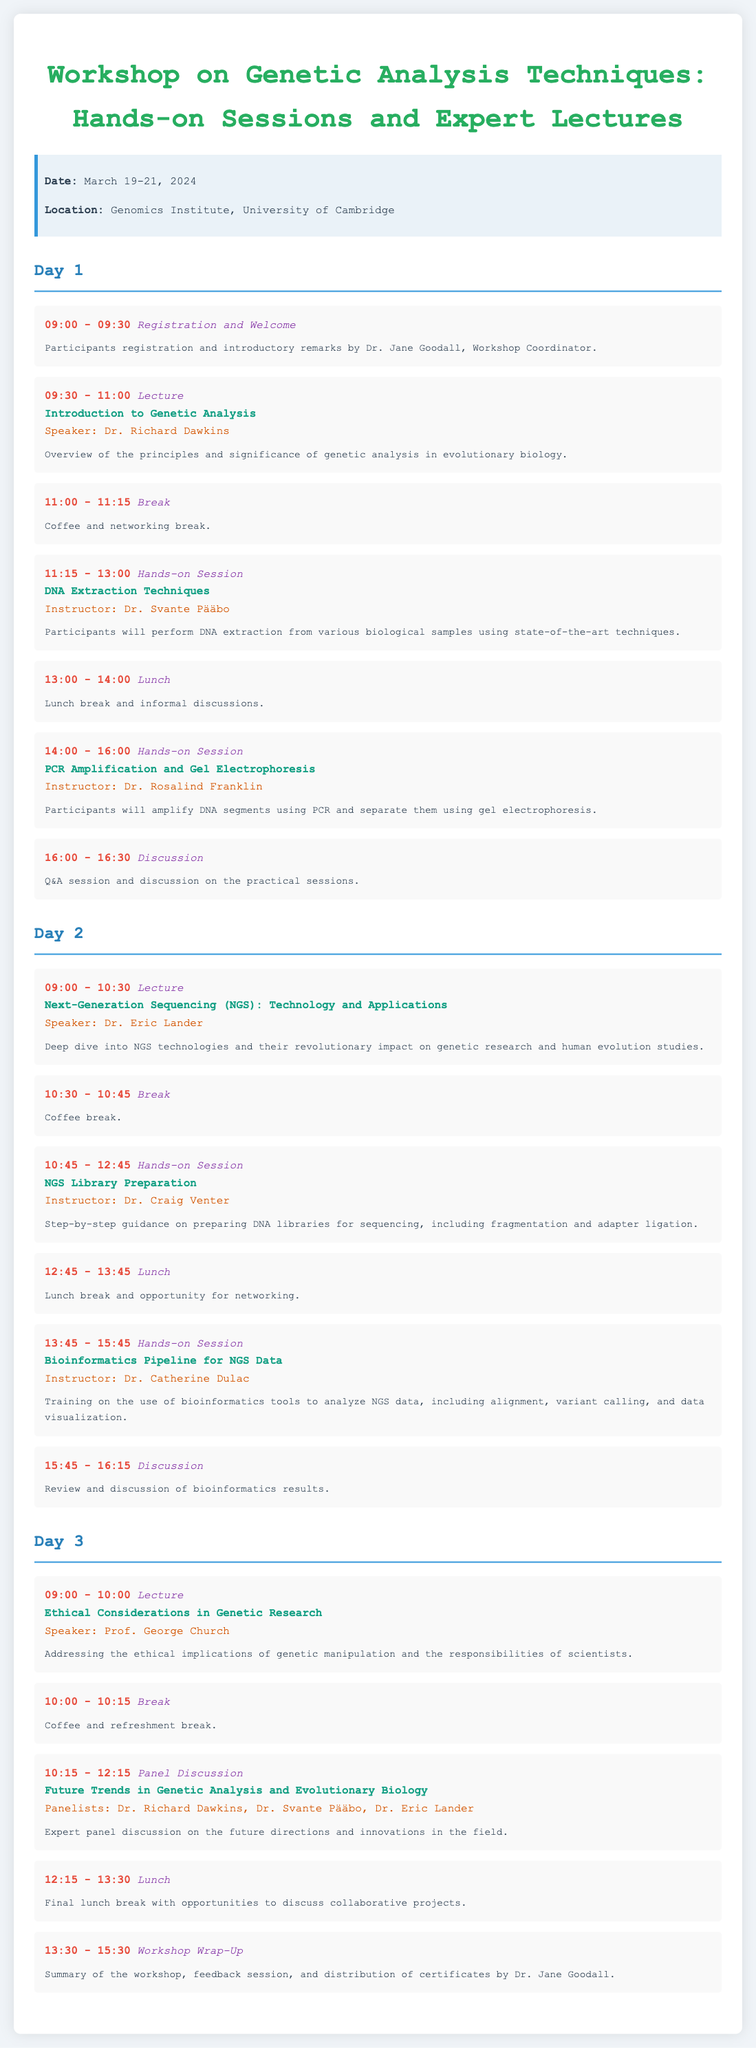what are the dates of the workshop? The dates of the workshop are clearly mentioned at the beginning of the document.
Answer: March 19-21, 2024 who is the speaker for the "Introduction to Genetic Analysis" lecture? The speaker for this lecture is listed in the schedule for Day 1.
Answer: Dr. Richard Dawkins how long is the coffee break on Day 2? The duration of the coffee break is specified in the schedule.
Answer: 15 minutes what is covered in the hands-on session led by Dr. Svante Pääbo? This hands-on session topic is stated in Day 1's schedule.
Answer: DNA Extraction Techniques who are the panelists for the discussion on "Future Trends in Genetic Analysis and Evolutionary Biology"? The names of the panelists are outlined in the Day 3 schedule under the panel discussion.
Answer: Dr. Richard Dawkins, Dr. Svante Pääbo, Dr. Eric Lander what is the main focus of Dr. George Church's lecture? The focus of the lecture is indicated in the title and details provided in the schedule.
Answer: Ethical Considerations in Genetic Research what activity concludes the workshop? The final activity for the workshop is specified in the last session of Day 3.
Answer: Workshop Wrap-Up 